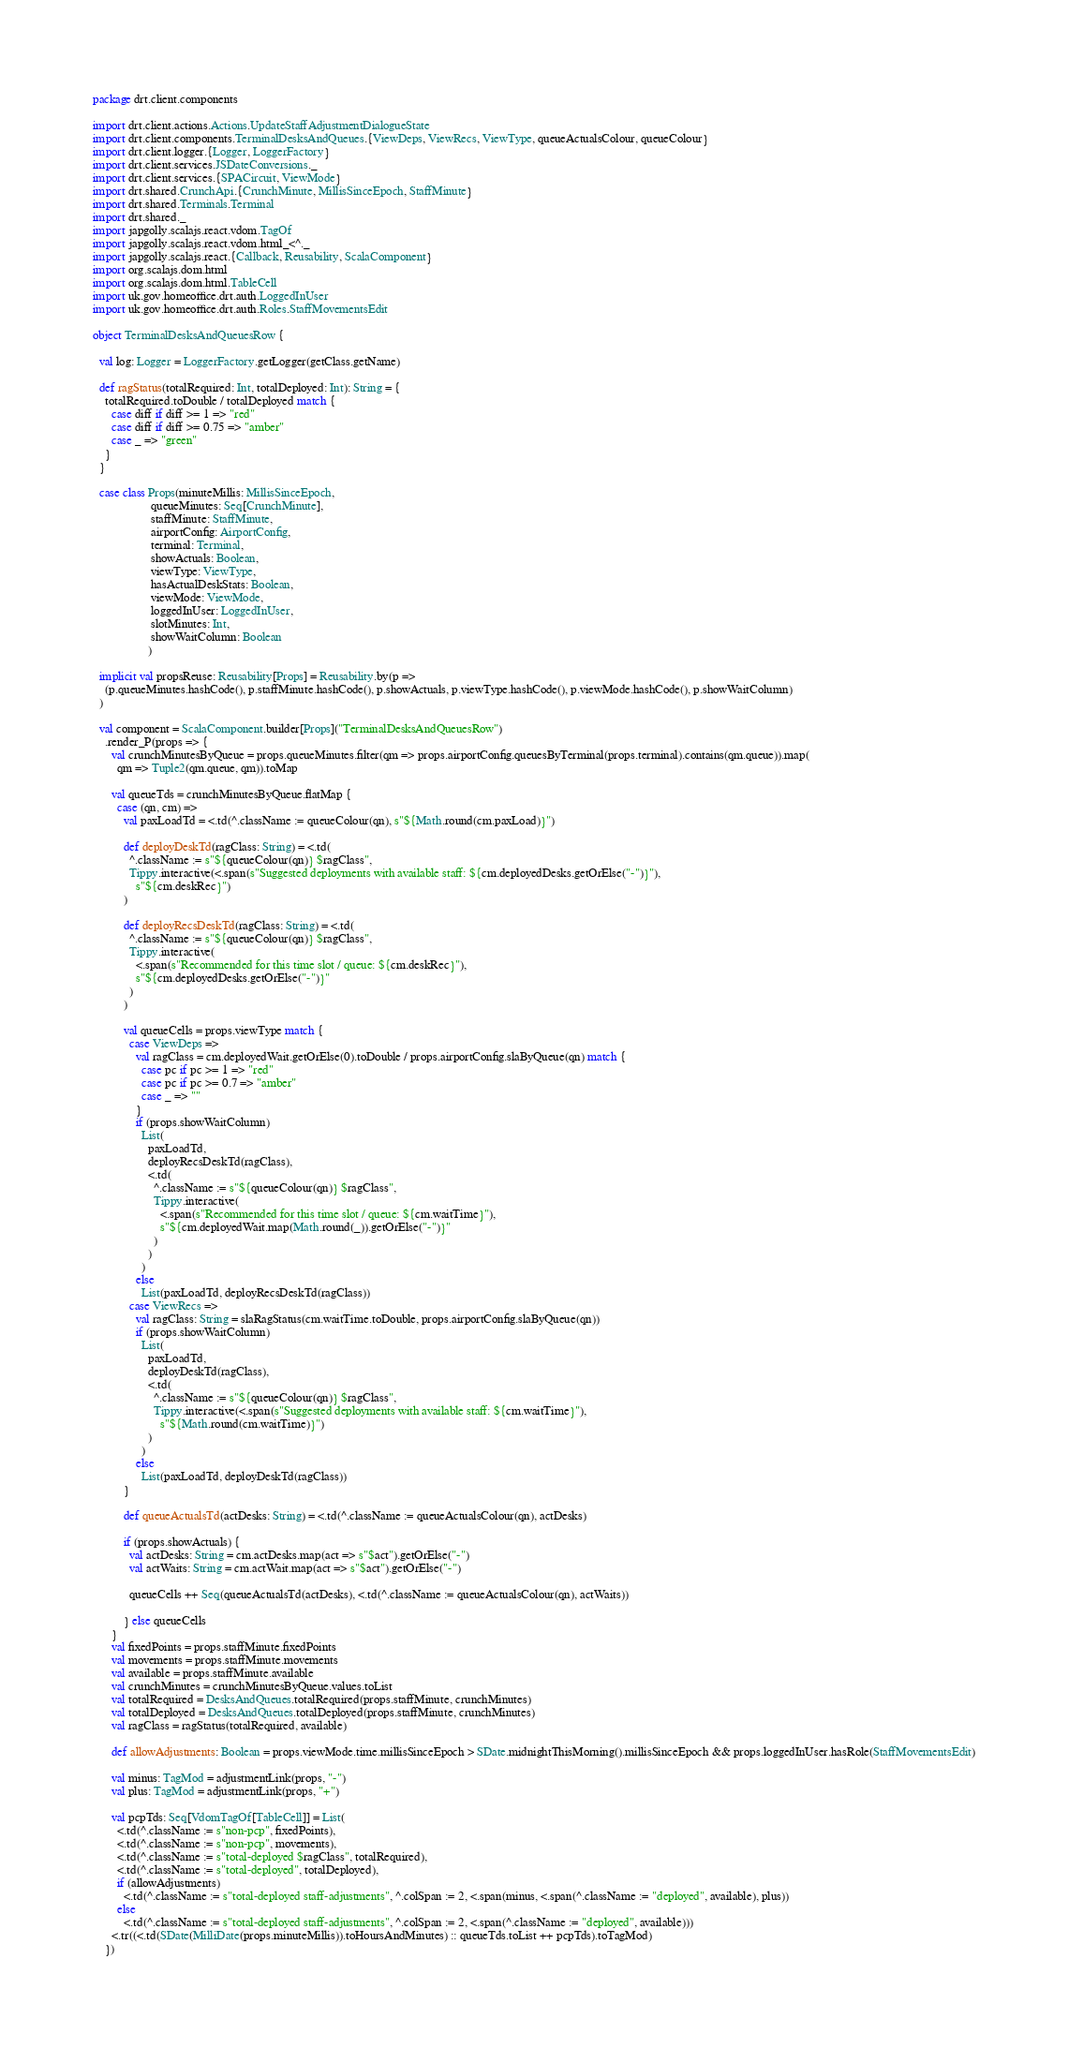<code> <loc_0><loc_0><loc_500><loc_500><_Scala_>package drt.client.components

import drt.client.actions.Actions.UpdateStaffAdjustmentDialogueState
import drt.client.components.TerminalDesksAndQueues.{ViewDeps, ViewRecs, ViewType, queueActualsColour, queueColour}
import drt.client.logger.{Logger, LoggerFactory}
import drt.client.services.JSDateConversions._
import drt.client.services.{SPACircuit, ViewMode}
import drt.shared.CrunchApi.{CrunchMinute, MillisSinceEpoch, StaffMinute}
import drt.shared.Terminals.Terminal
import drt.shared._
import japgolly.scalajs.react.vdom.TagOf
import japgolly.scalajs.react.vdom.html_<^._
import japgolly.scalajs.react.{Callback, Reusability, ScalaComponent}
import org.scalajs.dom.html
import org.scalajs.dom.html.TableCell
import uk.gov.homeoffice.drt.auth.LoggedInUser
import uk.gov.homeoffice.drt.auth.Roles.StaffMovementsEdit

object TerminalDesksAndQueuesRow {

  val log: Logger = LoggerFactory.getLogger(getClass.getName)

  def ragStatus(totalRequired: Int, totalDeployed: Int): String = {
    totalRequired.toDouble / totalDeployed match {
      case diff if diff >= 1 => "red"
      case diff if diff >= 0.75 => "amber"
      case _ => "green"
    }
  }

  case class Props(minuteMillis: MillisSinceEpoch,
                   queueMinutes: Seq[CrunchMinute],
                   staffMinute: StaffMinute,
                   airportConfig: AirportConfig,
                   terminal: Terminal,
                   showActuals: Boolean,
                   viewType: ViewType,
                   hasActualDeskStats: Boolean,
                   viewMode: ViewMode,
                   loggedInUser: LoggedInUser,
                   slotMinutes: Int,
                   showWaitColumn: Boolean
                  )

  implicit val propsReuse: Reusability[Props] = Reusability.by(p =>
    (p.queueMinutes.hashCode(), p.staffMinute.hashCode(), p.showActuals, p.viewType.hashCode(), p.viewMode.hashCode(), p.showWaitColumn)
  )

  val component = ScalaComponent.builder[Props]("TerminalDesksAndQueuesRow")
    .render_P(props => {
      val crunchMinutesByQueue = props.queueMinutes.filter(qm => props.airportConfig.queuesByTerminal(props.terminal).contains(qm.queue)).map(
        qm => Tuple2(qm.queue, qm)).toMap

      val queueTds = crunchMinutesByQueue.flatMap {
        case (qn, cm) =>
          val paxLoadTd = <.td(^.className := queueColour(qn), s"${Math.round(cm.paxLoad)}")

          def deployDeskTd(ragClass: String) = <.td(
            ^.className := s"${queueColour(qn)} $ragClass",
            Tippy.interactive(<.span(s"Suggested deployments with available staff: ${cm.deployedDesks.getOrElse("-")}"),
              s"${cm.deskRec}")
          )

          def deployRecsDeskTd(ragClass: String) = <.td(
            ^.className := s"${queueColour(qn)} $ragClass",
            Tippy.interactive(
              <.span(s"Recommended for this time slot / queue: ${cm.deskRec}"),
              s"${cm.deployedDesks.getOrElse("-")}"
            )
          )

          val queueCells = props.viewType match {
            case ViewDeps =>
              val ragClass = cm.deployedWait.getOrElse(0).toDouble / props.airportConfig.slaByQueue(qn) match {
                case pc if pc >= 1 => "red"
                case pc if pc >= 0.7 => "amber"
                case _ => ""
              }
              if (props.showWaitColumn)
                List(
                  paxLoadTd,
                  deployRecsDeskTd(ragClass),
                  <.td(
                    ^.className := s"${queueColour(qn)} $ragClass",
                    Tippy.interactive(
                      <.span(s"Recommended for this time slot / queue: ${cm.waitTime}"),
                      s"${cm.deployedWait.map(Math.round(_)).getOrElse("-")}"
                    )
                  )
                )
              else
                List(paxLoadTd, deployRecsDeskTd(ragClass))
            case ViewRecs =>
              val ragClass: String = slaRagStatus(cm.waitTime.toDouble, props.airportConfig.slaByQueue(qn))
              if (props.showWaitColumn)
                List(
                  paxLoadTd,
                  deployDeskTd(ragClass),
                  <.td(
                    ^.className := s"${queueColour(qn)} $ragClass",
                    Tippy.interactive(<.span(s"Suggested deployments with available staff: ${cm.waitTime}"),
                      s"${Math.round(cm.waitTime)}")
                  )
                )
              else
                List(paxLoadTd, deployDeskTd(ragClass))
          }

          def queueActualsTd(actDesks: String) = <.td(^.className := queueActualsColour(qn), actDesks)

          if (props.showActuals) {
            val actDesks: String = cm.actDesks.map(act => s"$act").getOrElse("-")
            val actWaits: String = cm.actWait.map(act => s"$act").getOrElse("-")

            queueCells ++ Seq(queueActualsTd(actDesks), <.td(^.className := queueActualsColour(qn), actWaits))

          } else queueCells
      }
      val fixedPoints = props.staffMinute.fixedPoints
      val movements = props.staffMinute.movements
      val available = props.staffMinute.available
      val crunchMinutes = crunchMinutesByQueue.values.toList
      val totalRequired = DesksAndQueues.totalRequired(props.staffMinute, crunchMinutes)
      val totalDeployed = DesksAndQueues.totalDeployed(props.staffMinute, crunchMinutes)
      val ragClass = ragStatus(totalRequired, available)

      def allowAdjustments: Boolean = props.viewMode.time.millisSinceEpoch > SDate.midnightThisMorning().millisSinceEpoch && props.loggedInUser.hasRole(StaffMovementsEdit)

      val minus: TagMod = adjustmentLink(props, "-")
      val plus: TagMod = adjustmentLink(props, "+")

      val pcpTds: Seq[VdomTagOf[TableCell]] = List(
        <.td(^.className := s"non-pcp", fixedPoints),
        <.td(^.className := s"non-pcp", movements),
        <.td(^.className := s"total-deployed $ragClass", totalRequired),
        <.td(^.className := s"total-deployed", totalDeployed),
        if (allowAdjustments)
          <.td(^.className := s"total-deployed staff-adjustments", ^.colSpan := 2, <.span(minus, <.span(^.className := "deployed", available), plus))
        else
          <.td(^.className := s"total-deployed staff-adjustments", ^.colSpan := 2, <.span(^.className := "deployed", available)))
      <.tr((<.td(SDate(MilliDate(props.minuteMillis)).toHoursAndMinutes) :: queueTds.toList ++ pcpTds).toTagMod)
    })</code> 